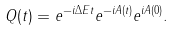Convert formula to latex. <formula><loc_0><loc_0><loc_500><loc_500>Q ( t ) = e ^ { - i \Delta E t } e ^ { - i A ( t ) } e ^ { i A ( 0 ) } .</formula> 